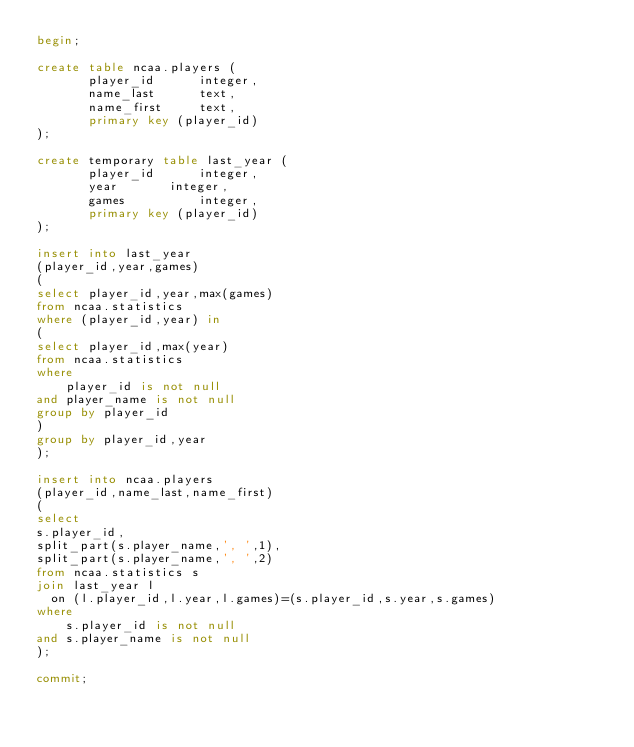Convert code to text. <code><loc_0><loc_0><loc_500><loc_500><_SQL_>begin;

create table ncaa.players (
       player_id	  integer,
       name_last	  text,
       name_first	  text,
       primary key (player_id)
);

create temporary table last_year (
       player_id	  integer,
       year		  integer,
       games		  integer,       
       primary key (player_id)
);

insert into last_year
(player_id,year,games)
(
select player_id,year,max(games)
from ncaa.statistics
where (player_id,year) in
(
select player_id,max(year)
from ncaa.statistics
where
    player_id is not null
and player_name is not null
group by player_id
)
group by player_id,year
);

insert into ncaa.players
(player_id,name_last,name_first)
(
select
s.player_id,
split_part(s.player_name,', ',1),
split_part(s.player_name,', ',2)
from ncaa.statistics s
join last_year l
  on (l.player_id,l.year,l.games)=(s.player_id,s.year,s.games)
where
    s.player_id is not null
and s.player_name is not null
);

commit;
</code> 